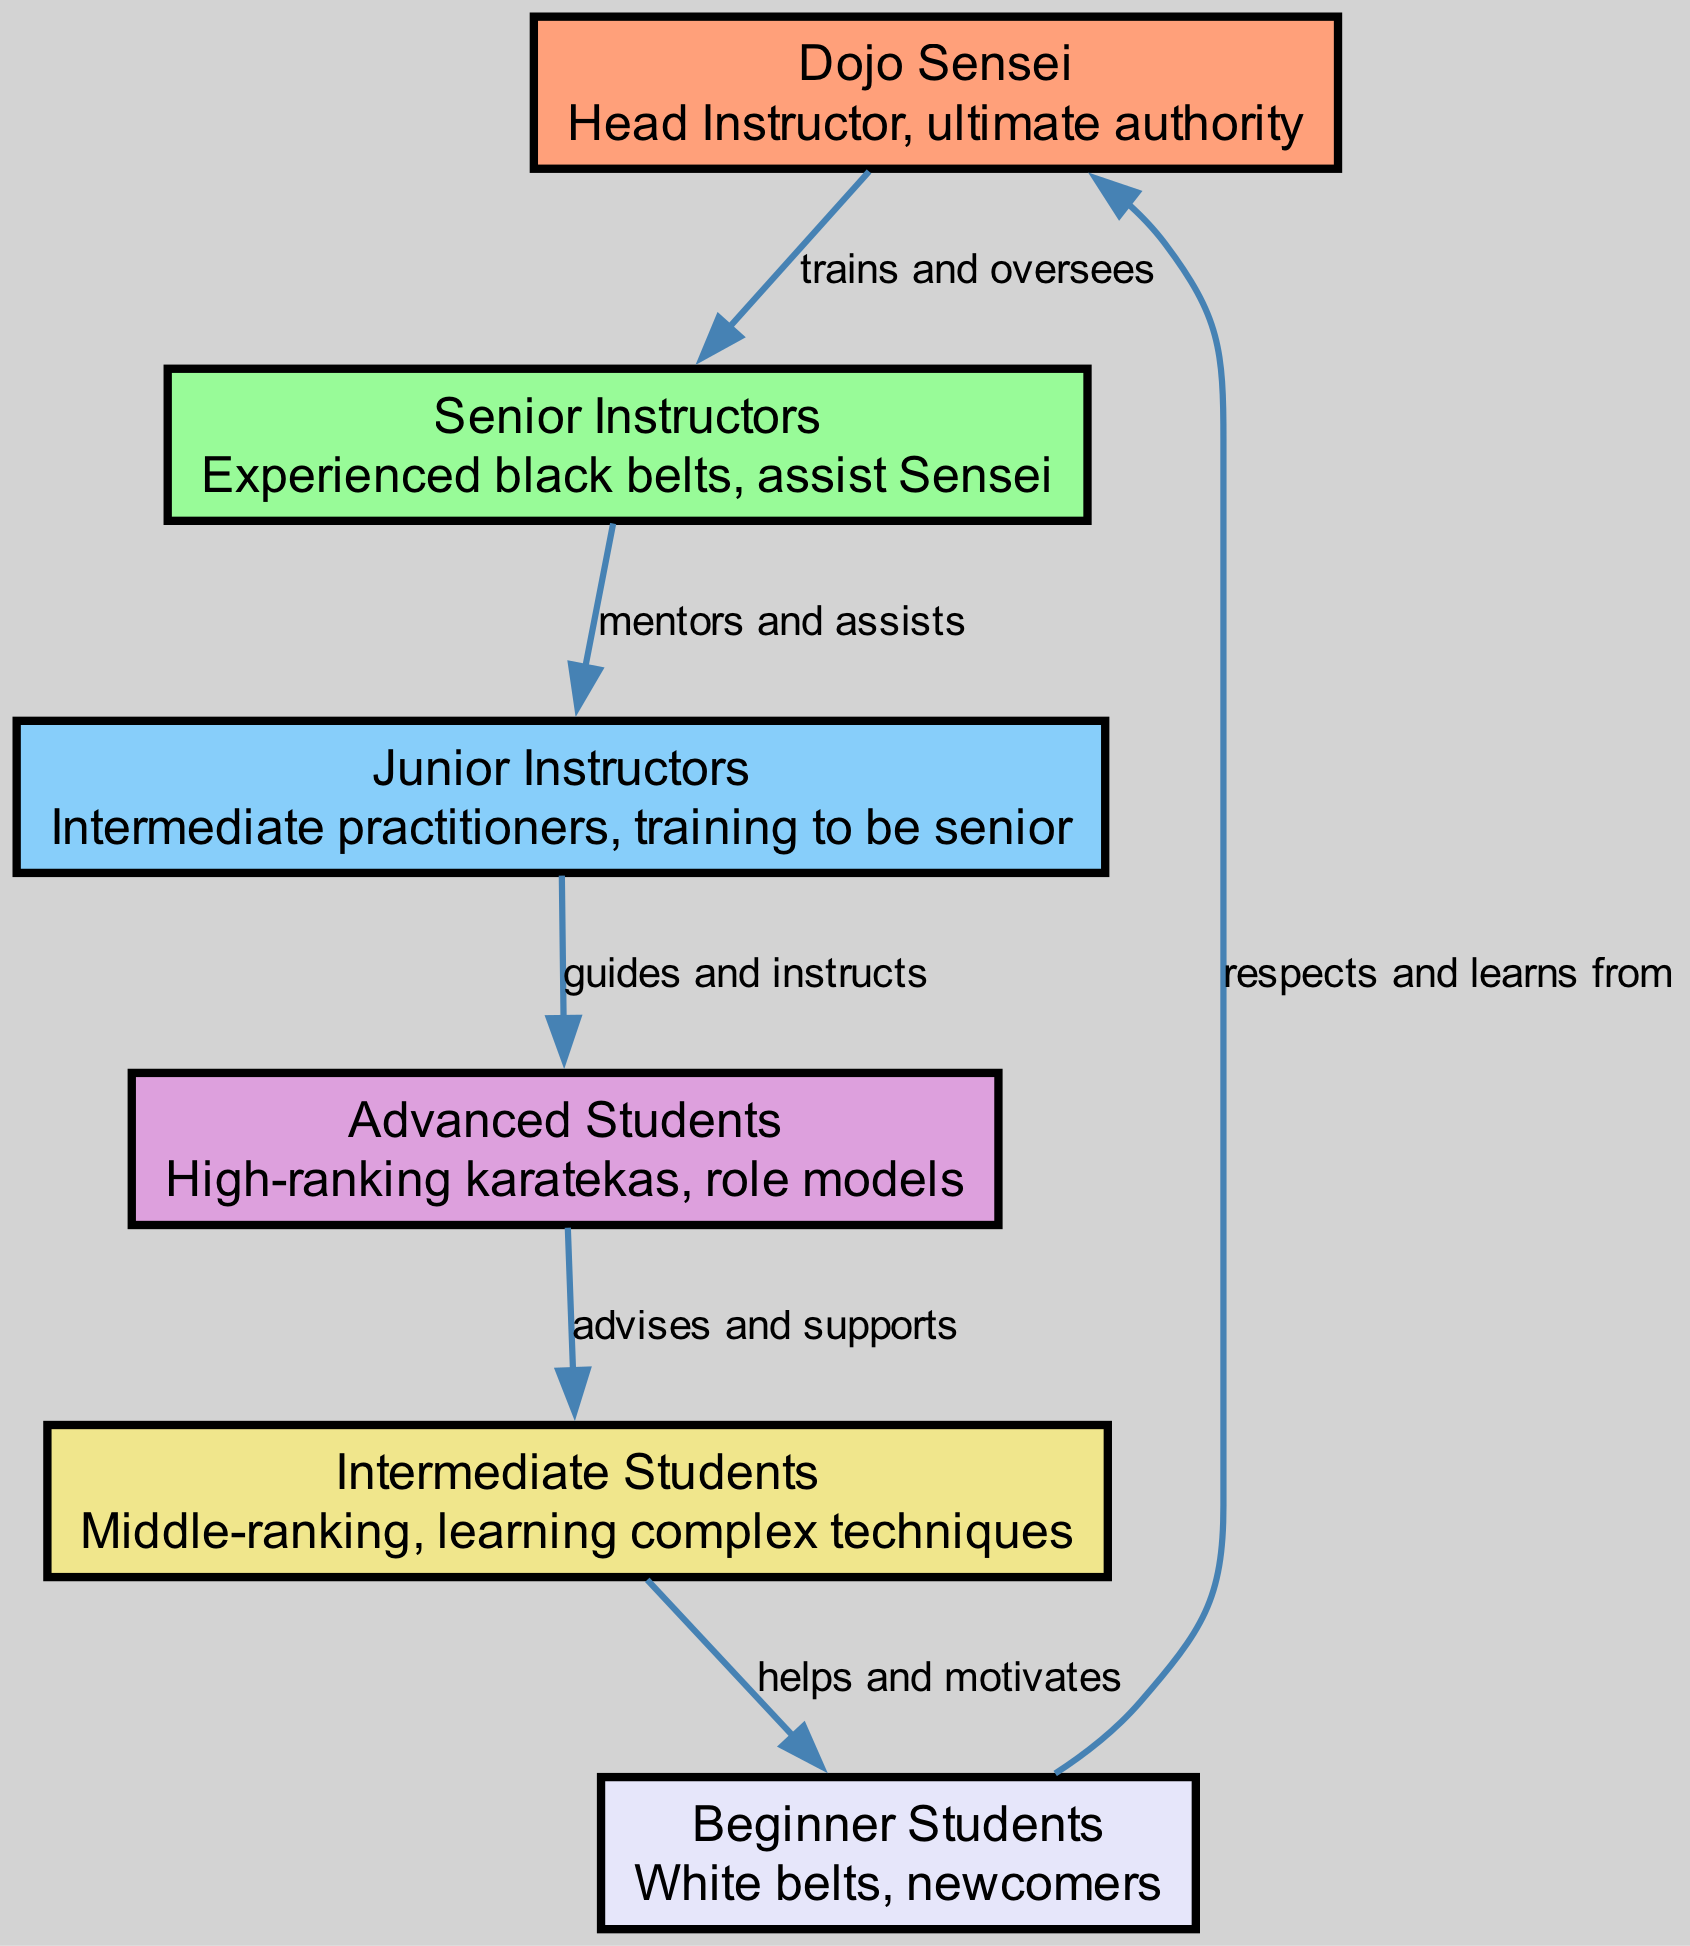What is the title of the highest authority in the dojo? The highest authority in the dojo is represented by the node labeled "Dojo Sensei." This node indicates that the Dojo Sensei serves as the head instructor, having ultimate authority over the dojo operations and training.
Answer: Dojo Sensei How many total nodes are there in the diagram? The diagram consists of six distinct nodes, each representing a different role within the dojo's hierarchy. These nodes are interconnected by edges that illustrate their relationships.
Answer: 6 What is the relationship between the Senior Instructors and Junior Instructors? The edge connecting "Senior Instructors" to "Junior Instructors" is labeled "mentors and assists," indicating that Senior Instructors provide guidance and support to Junior Instructors in their training journey.
Answer: mentors and assists Which group do the Intermediate Students provide help to? There is an edge leading from "Intermediate Students" to "Beginner Students," with the label "helps and motivates," which indicates that Intermediate Students are responsible for assisting the newcomers in their martial arts training.
Answer: Beginner Students Who are the role models for the Intermediate Students? The diagram shows an edge from "Advanced Students" to "Intermediate Students" labeled "advises and supports." This implies that Advanced Students serve as role models for those in the Intermediate Students category, offering them guidance and support.
Answer: Advanced Students How does the respect flow within the dojo hierarchy? The edge from "Beginner Students" to "Dojo Sensei" is labeled "respects and learns from." This indicates that Beginner Students look up to the Dojo Sensei, showing respect and learning the fundamentals of martial arts through their guidance.
Answer: Dojo Sensei What color indicates the Senior Instructors in the diagram? The diagram uses a custom color palette wherein the node for "Senior Instructors" is associated with a specific color code. By identifying the node number that corresponds to Senior Instructors and checking its color assignment, we find that it is represented in a light green color.
Answer: #98FB98 From which group do the Advanced Students receive their instructions? The edge labeled "guides and instructs" connects "Junior Instructors" to "Advanced Students." This indicates that Advanced Students gain their skills and directed training from Junior Instructors, as they provide both guidance and instructional support to them.
Answer: Junior Instructors What is the goal of the Dojo Sensei in relation to the Senior Instructors? The edge labeled "trains and oversees" connects "Dojo Sensei" to "Senior Instructors." This indicates that the primary goal of the Dojo Sensei, regarding the Senior Instructors, is to provide training and oversee their performance, ensuring they are effective in assisting the students.
Answer: trains and oversees 